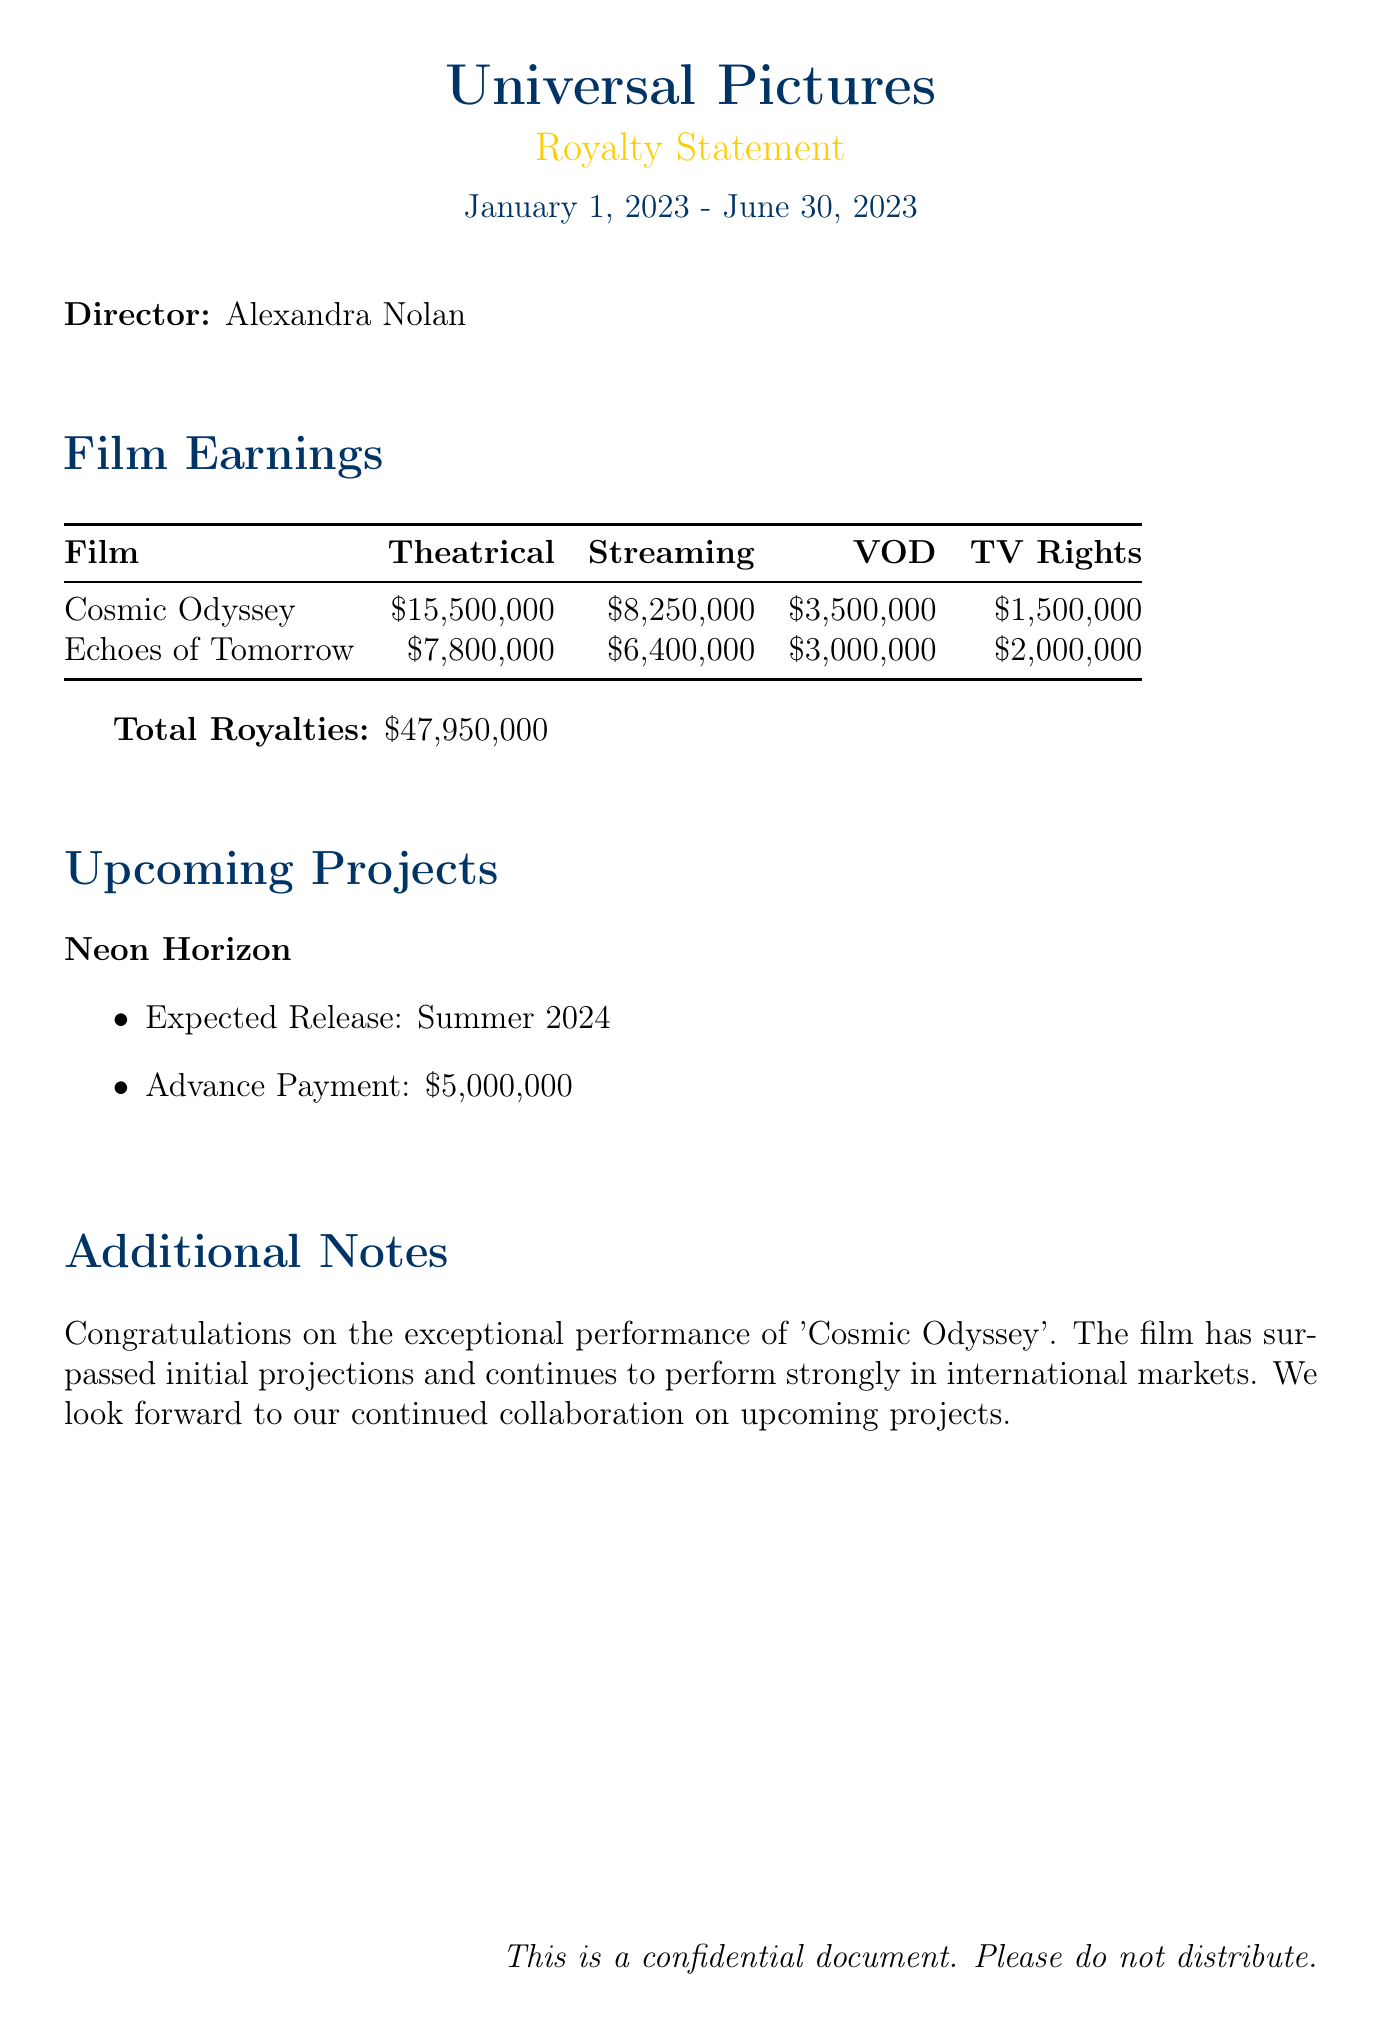What is the studio name? The studio name can be found at the top of the document, identified as Universal Pictures.
Answer: Universal Pictures Who is the director? The director's name appears in the section detailing the royalties and is Alexandra Nolan.
Answer: Alexandra Nolan What is the total earnings for Cosmic Odyssey? The total earnings for Cosmic Odyssey is specified in the earnings breakdown, listed as $28,750,000.
Answer: $28,750,000 How much did Echoes of Tomorrow earn from streaming? The amount earned from the streaming channel for Echoes of Tomorrow is clearly listed in the document as $6,400,000.
Answer: $6,400,000 What is the total royalties amount? The total royalties amount is provided at the bottom of the film earnings section and is stated as $47,950,000.
Answer: $47,950,000 Which film has the highest earnings? The film with the highest earnings is determined by comparing the total earnings figures, which is Cosmic Odyssey.
Answer: Cosmic Odyssey What is the expected release time for Neon Horizon? The expected release time for the upcoming project is mentioned as Summer 2024.
Answer: Summer 2024 What advance payment is associated with Neon Horizon? The advance payment for Neon Horizon is explicitly mentioned as $5,000,000 in the upcoming projects section.
Answer: $5,000,000 What is mentioned in the additional notes section? The additional notes section includes a congratulatory message about Cosmic Odyssey's performance and a positive outlook for future projects.
Answer: Congratulations on the exceptional performance of 'Cosmic Odyssey' 